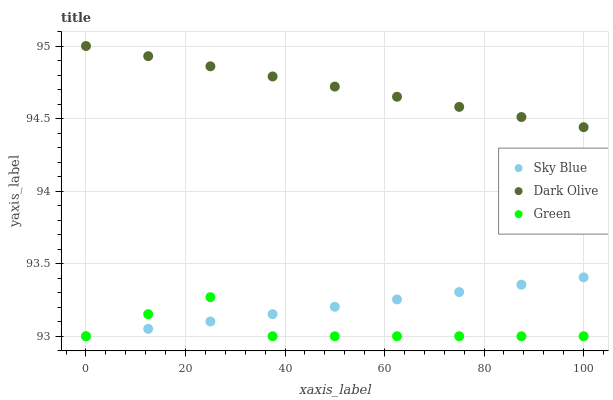Does Green have the minimum area under the curve?
Answer yes or no. Yes. Does Dark Olive have the maximum area under the curve?
Answer yes or no. Yes. Does Dark Olive have the minimum area under the curve?
Answer yes or no. No. Does Green have the maximum area under the curve?
Answer yes or no. No. Is Sky Blue the smoothest?
Answer yes or no. Yes. Is Green the roughest?
Answer yes or no. Yes. Is Dark Olive the smoothest?
Answer yes or no. No. Is Dark Olive the roughest?
Answer yes or no. No. Does Sky Blue have the lowest value?
Answer yes or no. Yes. Does Dark Olive have the lowest value?
Answer yes or no. No. Does Dark Olive have the highest value?
Answer yes or no. Yes. Does Green have the highest value?
Answer yes or no. No. Is Sky Blue less than Dark Olive?
Answer yes or no. Yes. Is Dark Olive greater than Sky Blue?
Answer yes or no. Yes. Does Green intersect Sky Blue?
Answer yes or no. Yes. Is Green less than Sky Blue?
Answer yes or no. No. Is Green greater than Sky Blue?
Answer yes or no. No. Does Sky Blue intersect Dark Olive?
Answer yes or no. No. 